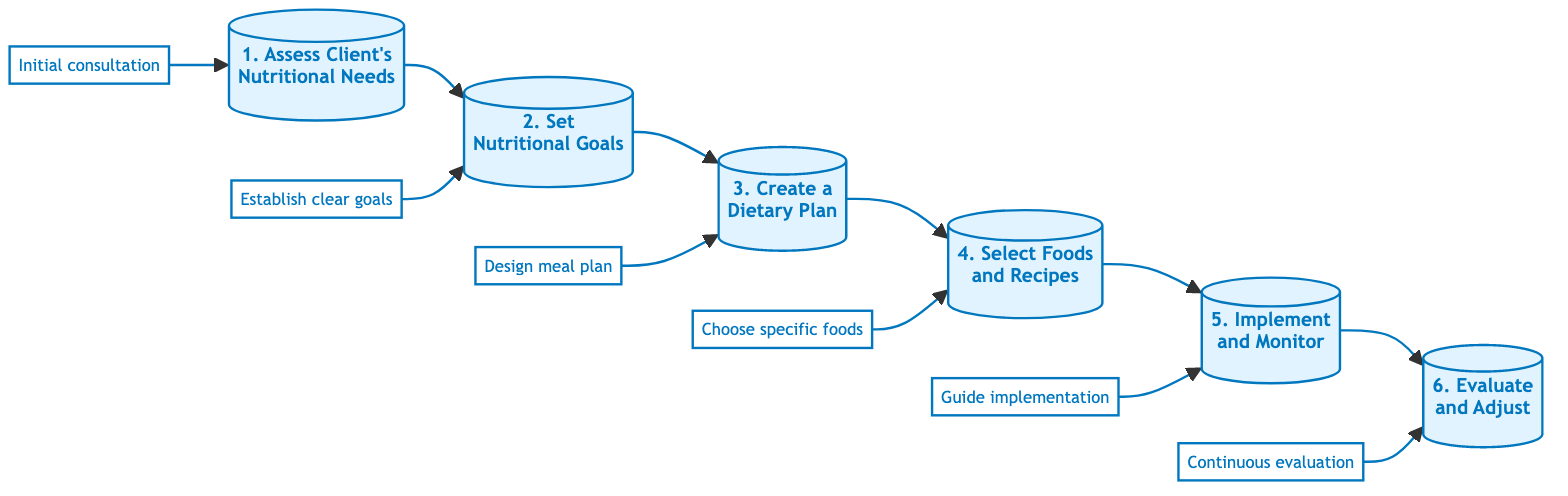What is the first step in the diagram? The diagram begins with "Assess Client's Nutritional Needs," which is the first node listed.
Answer: Assess Client's Nutritional Needs How many steps are there in total? By counting the nodes in the diagram, there are a total of six steps, starting from the first step to the last.
Answer: 6 What is the last step in the flowchart? The last step in the flowchart is "Evaluate and Adjust," which is located at the end of the sequence.
Answer: Evaluate and Adjust Which step involves setting clear goals? The step that involves setting clear goals is the second step, titled "Set Nutritional Goals."
Answer: Set Nutritional Goals What follows the "Create a Dietary Plan" step? After the "Create a Dietary Plan" step, the next step is "Select Foods and Recipes." This is determined by following the flow from the third node to the fourth.
Answer: Select Foods and Recipes What is the relationship between "Implement and Monitor" and "Evaluate and Adjust"? "Implement and Monitor" is the fifth step, which directly leads to the sixth step, "Evaluate and Adjust," indicating a progression from implementation to evaluation.
Answer: Implement and Monitor → Evaluate and Adjust What action is associated with the first step? The first step, "Assess Client's Nutritional Needs," is associated with the action of conducting an initial consultation to assess dietary requirements.
Answer: Conduct initial consultation Which step comes before "Select Foods and Recipes"? The step that comes directly before "Select Foods and Recipes" is "Create a Dietary Plan," creating a chronological relationship between these two steps.
Answer: Create a Dietary Plan What is required to successfully evaluate the meal plan? To successfully evaluate the meal plan, continuous evaluation based on the client's feedback and progress is required, as indicated in the last step.
Answer: Continuous evaluation 